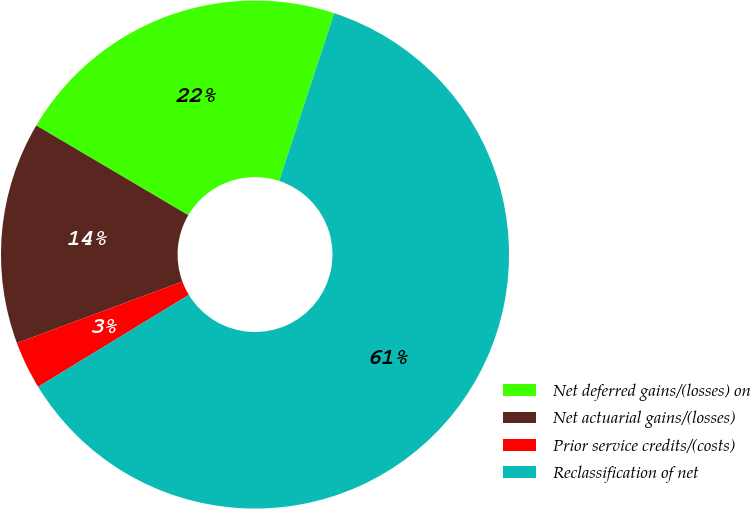Convert chart. <chart><loc_0><loc_0><loc_500><loc_500><pie_chart><fcel>Net deferred gains/(losses) on<fcel>Net actuarial gains/(losses)<fcel>Prior service credits/(costs)<fcel>Reclassification of net<nl><fcel>21.56%<fcel>14.15%<fcel>3.05%<fcel>61.24%<nl></chart> 